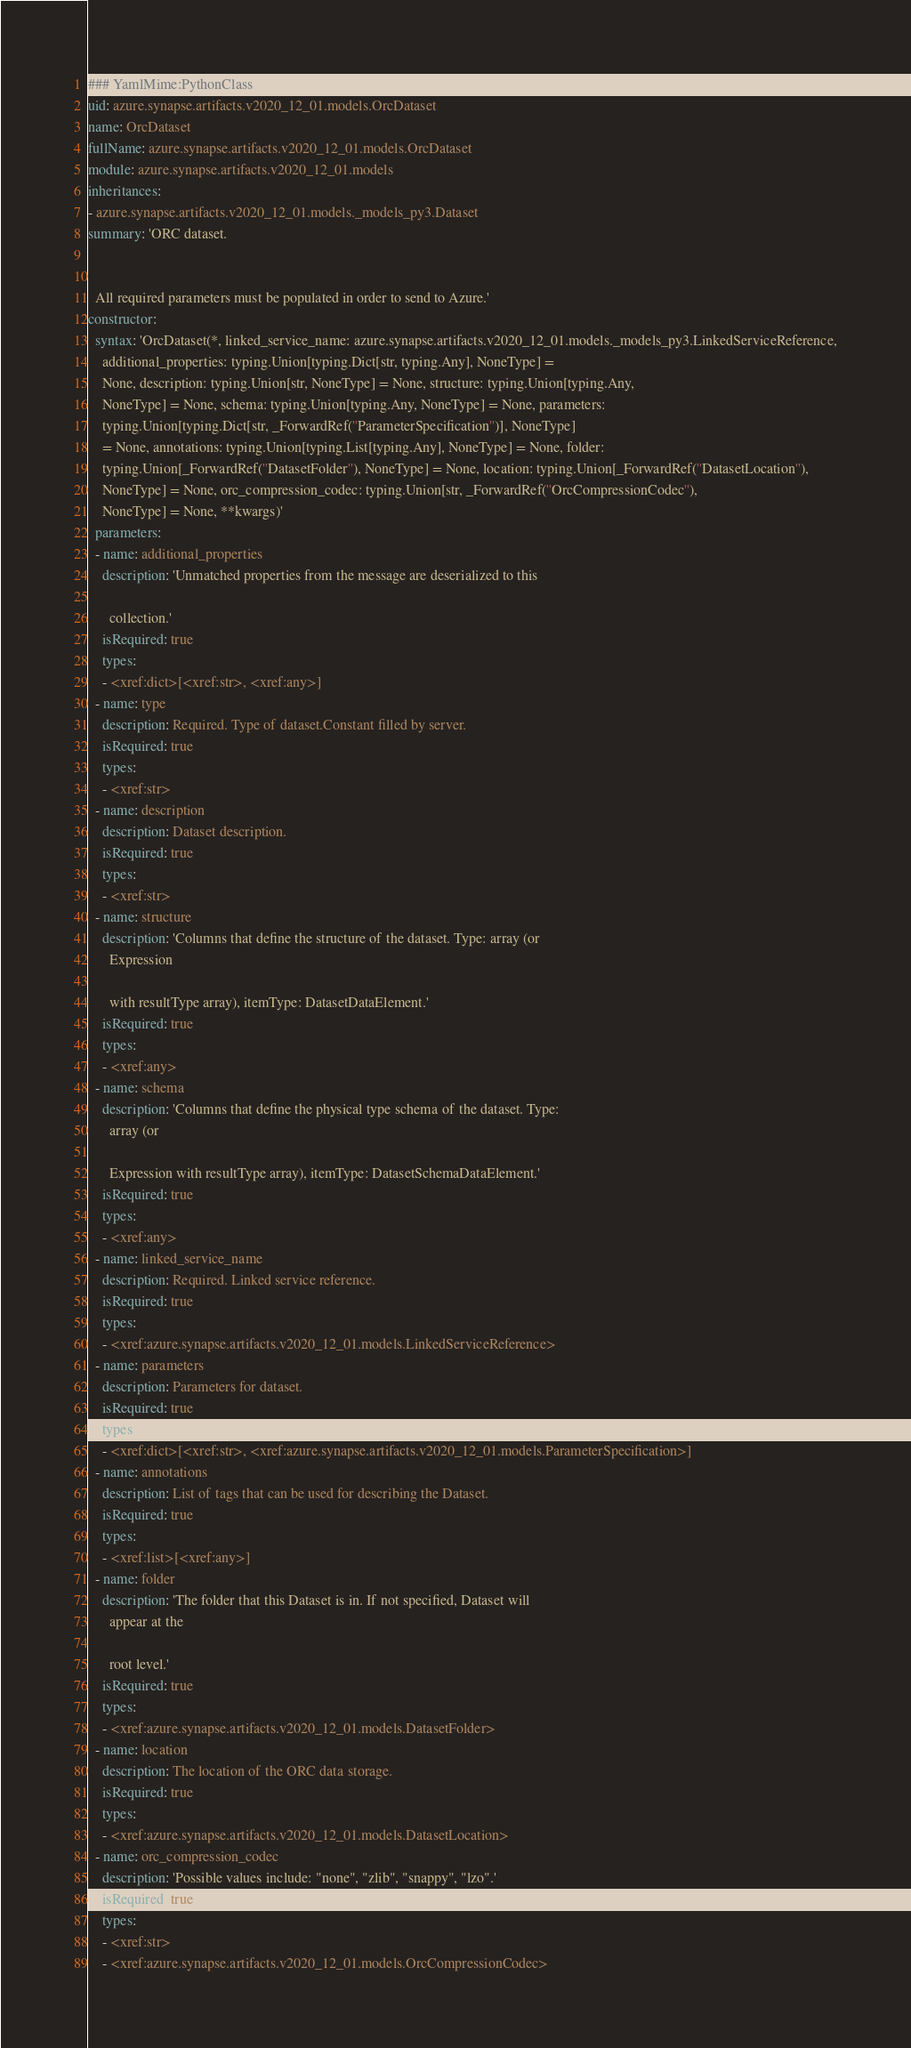Convert code to text. <code><loc_0><loc_0><loc_500><loc_500><_YAML_>### YamlMime:PythonClass
uid: azure.synapse.artifacts.v2020_12_01.models.OrcDataset
name: OrcDataset
fullName: azure.synapse.artifacts.v2020_12_01.models.OrcDataset
module: azure.synapse.artifacts.v2020_12_01.models
inheritances:
- azure.synapse.artifacts.v2020_12_01.models._models_py3.Dataset
summary: 'ORC dataset.


  All required parameters must be populated in order to send to Azure.'
constructor:
  syntax: 'OrcDataset(*, linked_service_name: azure.synapse.artifacts.v2020_12_01.models._models_py3.LinkedServiceReference,
    additional_properties: typing.Union[typing.Dict[str, typing.Any], NoneType] =
    None, description: typing.Union[str, NoneType] = None, structure: typing.Union[typing.Any,
    NoneType] = None, schema: typing.Union[typing.Any, NoneType] = None, parameters:
    typing.Union[typing.Dict[str, _ForwardRef(''ParameterSpecification'')], NoneType]
    = None, annotations: typing.Union[typing.List[typing.Any], NoneType] = None, folder:
    typing.Union[_ForwardRef(''DatasetFolder''), NoneType] = None, location: typing.Union[_ForwardRef(''DatasetLocation''),
    NoneType] = None, orc_compression_codec: typing.Union[str, _ForwardRef(''OrcCompressionCodec''),
    NoneType] = None, **kwargs)'
  parameters:
  - name: additional_properties
    description: 'Unmatched properties from the message are deserialized to this

      collection.'
    isRequired: true
    types:
    - <xref:dict>[<xref:str>, <xref:any>]
  - name: type
    description: Required. Type of dataset.Constant filled by server.
    isRequired: true
    types:
    - <xref:str>
  - name: description
    description: Dataset description.
    isRequired: true
    types:
    - <xref:str>
  - name: structure
    description: 'Columns that define the structure of the dataset. Type: array (or
      Expression

      with resultType array), itemType: DatasetDataElement.'
    isRequired: true
    types:
    - <xref:any>
  - name: schema
    description: 'Columns that define the physical type schema of the dataset. Type:
      array (or

      Expression with resultType array), itemType: DatasetSchemaDataElement.'
    isRequired: true
    types:
    - <xref:any>
  - name: linked_service_name
    description: Required. Linked service reference.
    isRequired: true
    types:
    - <xref:azure.synapse.artifacts.v2020_12_01.models.LinkedServiceReference>
  - name: parameters
    description: Parameters for dataset.
    isRequired: true
    types:
    - <xref:dict>[<xref:str>, <xref:azure.synapse.artifacts.v2020_12_01.models.ParameterSpecification>]
  - name: annotations
    description: List of tags that can be used for describing the Dataset.
    isRequired: true
    types:
    - <xref:list>[<xref:any>]
  - name: folder
    description: 'The folder that this Dataset is in. If not specified, Dataset will
      appear at the

      root level.'
    isRequired: true
    types:
    - <xref:azure.synapse.artifacts.v2020_12_01.models.DatasetFolder>
  - name: location
    description: The location of the ORC data storage.
    isRequired: true
    types:
    - <xref:azure.synapse.artifacts.v2020_12_01.models.DatasetLocation>
  - name: orc_compression_codec
    description: 'Possible values include: "none", "zlib", "snappy", "lzo".'
    isRequired: true
    types:
    - <xref:str>
    - <xref:azure.synapse.artifacts.v2020_12_01.models.OrcCompressionCodec>
</code> 